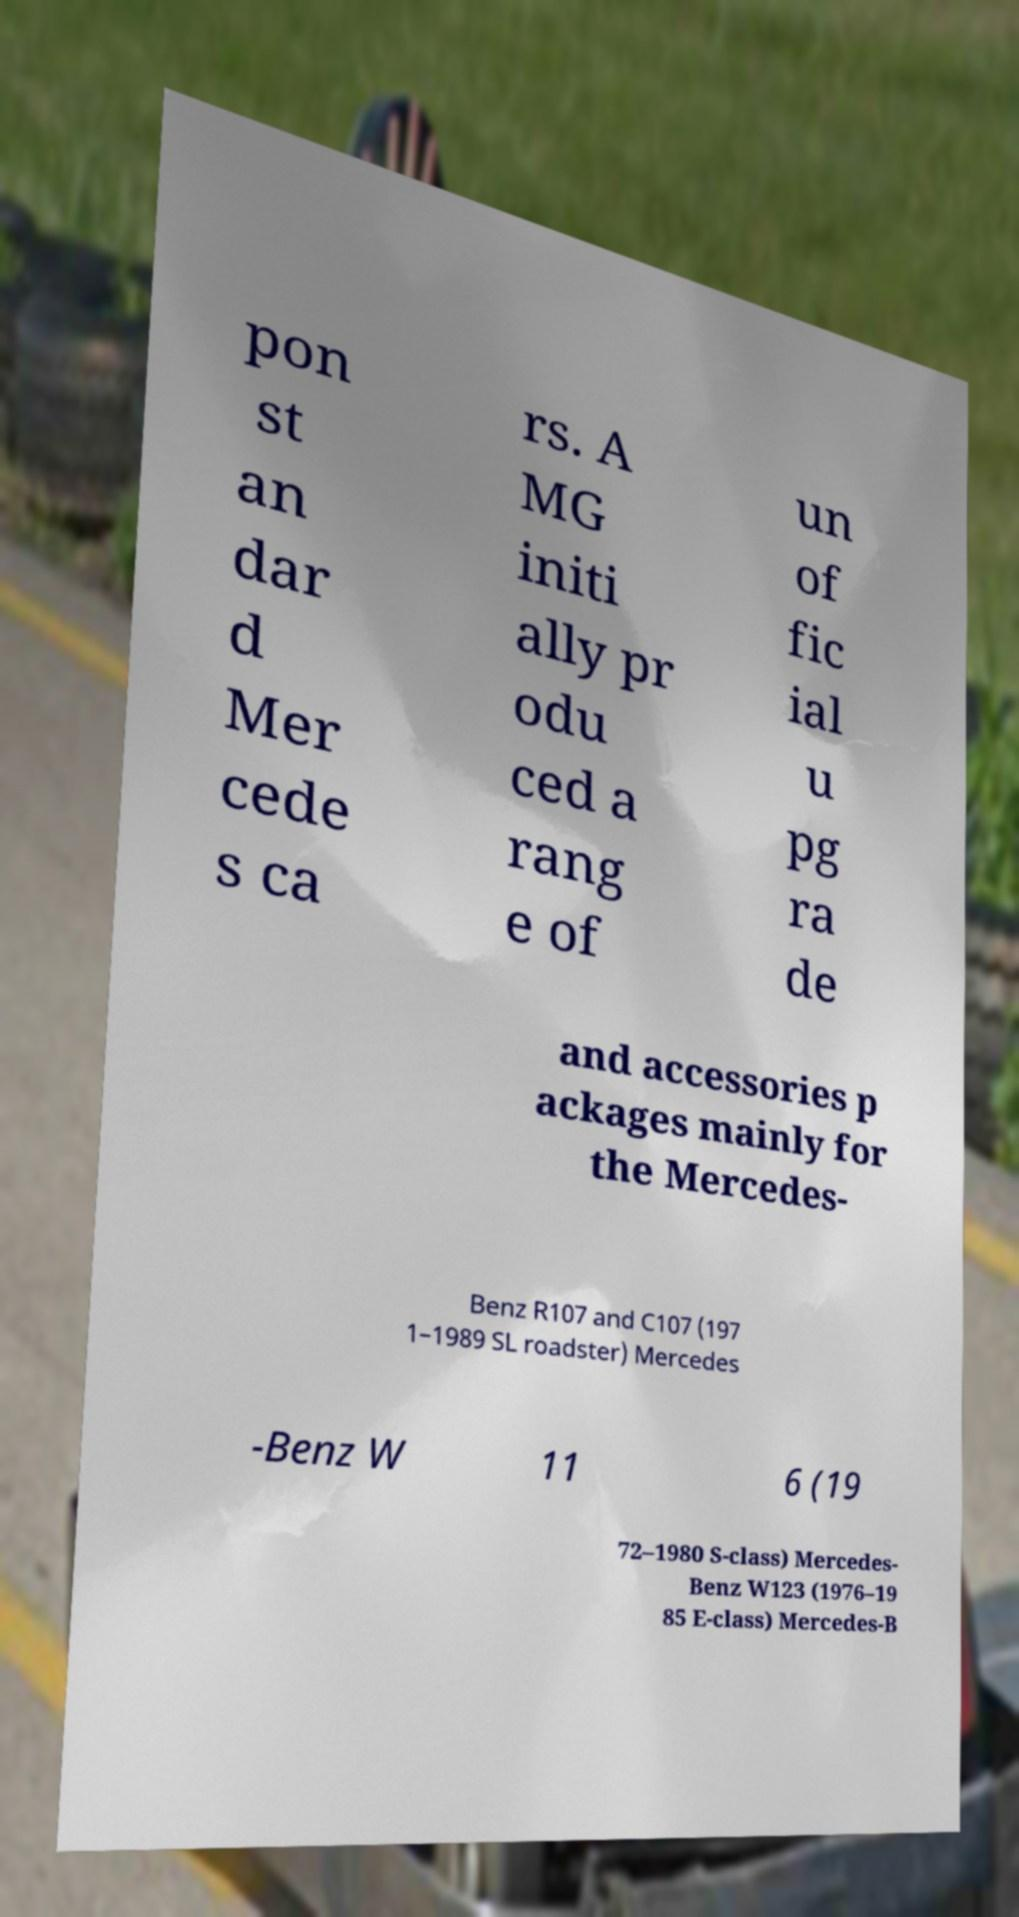Please read and relay the text visible in this image. What does it say? pon st an dar d Mer cede s ca rs. A MG initi ally pr odu ced a rang e of un of fic ial u pg ra de and accessories p ackages mainly for the Mercedes- Benz R107 and C107 (197 1–1989 SL roadster) Mercedes -Benz W 11 6 (19 72–1980 S-class) Mercedes- Benz W123 (1976–19 85 E-class) Mercedes-B 